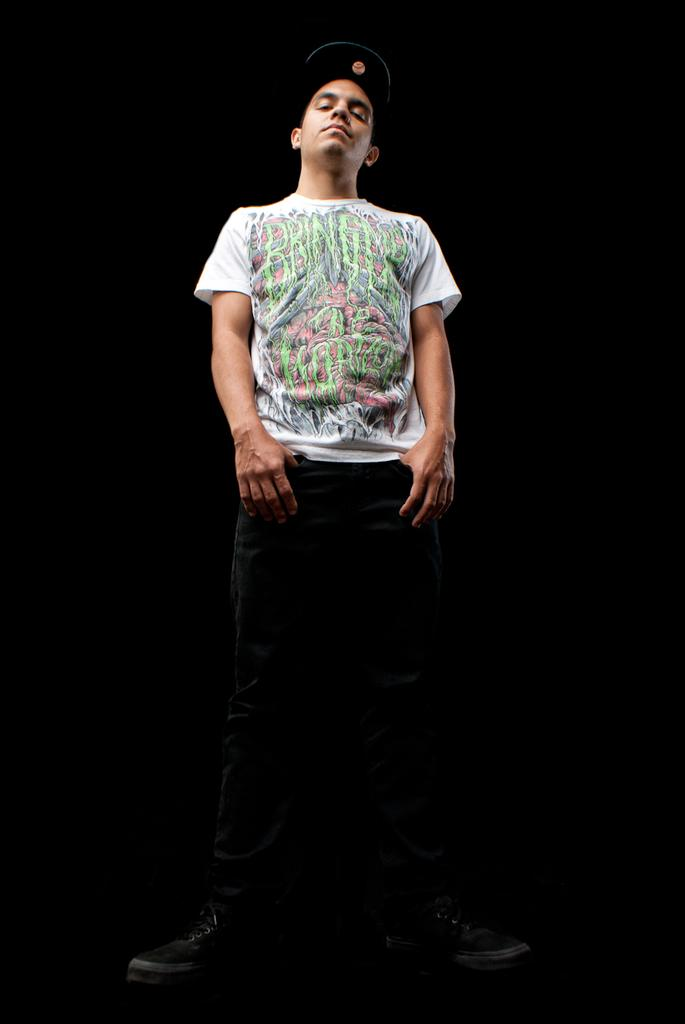Who is present in the image? There is a man in the image. What is the man wearing? The man is wearing a white t-shirt. What can be observed about the background of the image? The background of the image is dark. Are there any fairies visible in the image? There are no fairies present in the image. What type of amusement can be seen in the background of the image? There is no amusement depicted in the image; the background is dark. 